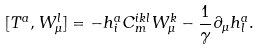Convert formula to latex. <formula><loc_0><loc_0><loc_500><loc_500>[ T ^ { a } , W _ { \mu } ^ { l } ] = - h ^ { a } _ { i } C ^ { i k l } _ { m } W _ { \mu } ^ { k } - \frac { 1 } { \gamma } \partial _ { \mu } h ^ { a } _ { l } .</formula> 